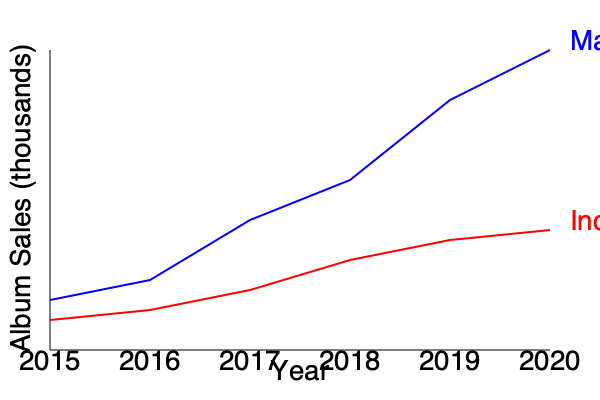Analyzing the graph, what trend can be observed in the album sales of indie jazz labels compared to major labels from 2015 to 2020, and what might this suggest about the future of indie jazz? To answer this question, let's analyze the graph step by step:

1. Identify the lines:
   - Blue line represents major labels
   - Red line represents indie jazz labels

2. Observe the trends:
   - Major labels: Show a steep upward trend from 2015 to 2020
   - Indie jazz labels: Show a gradual downward trend from 2015 to 2020

3. Compare the slopes:
   - Major labels have a steeper positive slope
   - Indie jazz labels have a gentler negative slope

4. Analyze the gap:
   - The gap between major and indie labels widens significantly from 2015 to 2020

5. Consider the implications:
   - Indie jazz labels are losing market share to major labels
   - The indie jazz market is shrinking while the overall market is growing

6. Future outlook:
   - If this trend continues, indie jazz labels may face increasing challenges
   - However, as an underdog supporter, this situation might create opportunities for innovation and niche marketing in the indie jazz scene

The trend suggests that while major labels are experiencing growth, indie jazz labels are facing declining sales. This could indicate a challenging future for indie jazz, but also an opportunity for these labels to adapt and find new ways to connect with their audience.
Answer: Indie jazz labels show declining sales while major labels grow, suggesting challenges but potential for innovation in the indie jazz scene. 